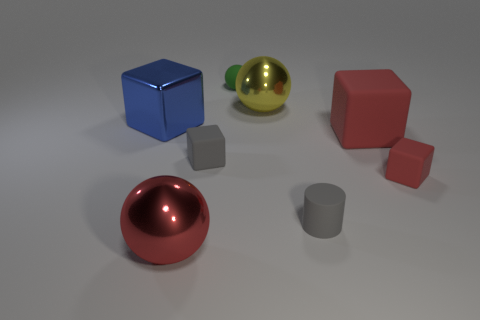Is the number of red objects in front of the tiny gray cylinder less than the number of rubber cylinders?
Your answer should be compact. No. Is the material of the tiny red object the same as the green thing?
Offer a very short reply. Yes. How many things are either red metal balls or big objects?
Offer a terse response. 4. How many large blue blocks have the same material as the big red sphere?
Your answer should be very brief. 1. What is the size of the other rubber object that is the same shape as the large yellow thing?
Give a very brief answer. Small. There is a big blue cube; are there any tiny cylinders to the left of it?
Give a very brief answer. No. What is the material of the large yellow thing?
Ensure brevity in your answer.  Metal. There is a big metallic sphere that is behind the large blue shiny thing; is it the same color as the tiny rubber sphere?
Ensure brevity in your answer.  No. Is there anything else that is the same shape as the large blue thing?
Your response must be concise. Yes. What color is the other large thing that is the same shape as the big red rubber thing?
Provide a succinct answer. Blue. 